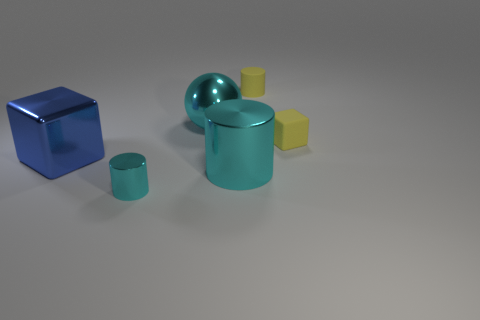How many cylinders are either blue objects or large green metal objects?
Offer a terse response. 0. There is a tiny object that is the same material as the yellow cylinder; what color is it?
Keep it short and to the point. Yellow. Is the number of large cyan metallic spheres less than the number of tiny brown matte cubes?
Give a very brief answer. No. Does the large thing that is to the left of the small cyan metallic thing have the same shape as the small yellow matte thing that is on the right side of the tiny yellow cylinder?
Your response must be concise. Yes. How many objects are tiny yellow cubes or metallic things?
Your response must be concise. 5. The matte thing that is the same size as the yellow rubber cylinder is what color?
Your answer should be very brief. Yellow. There is a cube that is on the left side of the tiny metallic cylinder; what number of things are to the right of it?
Ensure brevity in your answer.  5. What number of objects are in front of the big ball and on the left side of the matte cylinder?
Your answer should be compact. 3. What number of objects are cylinders behind the small rubber block or cyan objects on the right side of the big cyan shiny ball?
Your response must be concise. 2. What number of other objects are the same size as the shiny ball?
Give a very brief answer. 2. 